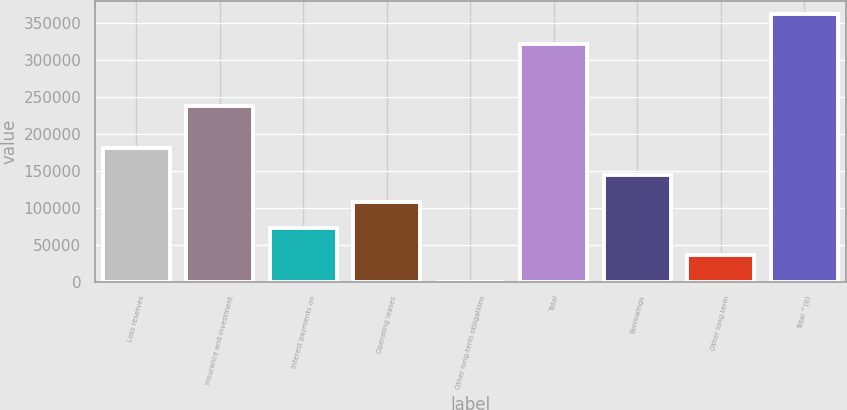Convert chart to OTSL. <chart><loc_0><loc_0><loc_500><loc_500><bar_chart><fcel>Loss reserves<fcel>Insurance and investment<fcel>Interest payments on<fcel>Operating leases<fcel>Other long-term obligations<fcel>Total<fcel>Borrowings<fcel>Other long-term<fcel>Total ^(b)<nl><fcel>181220<fcel>238343<fcel>72493.8<fcel>108736<fcel>10<fcel>321883<fcel>144978<fcel>36251.9<fcel>362429<nl></chart> 